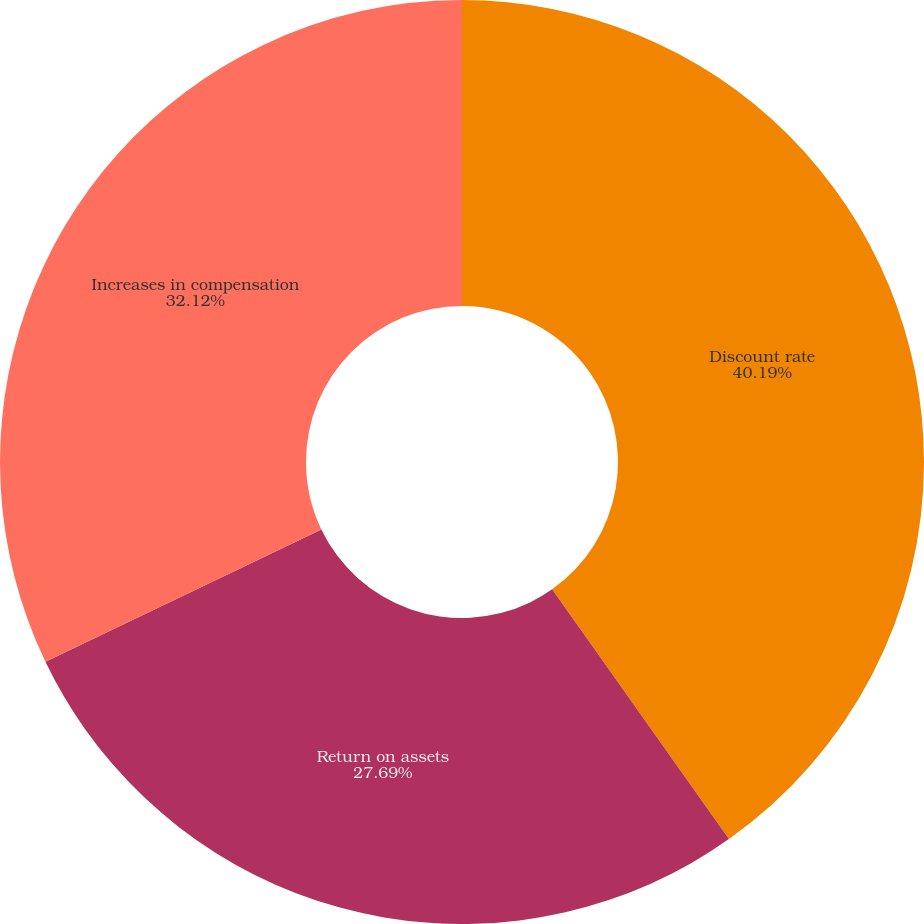Convert chart to OTSL. <chart><loc_0><loc_0><loc_500><loc_500><pie_chart><fcel>Discount rate<fcel>Return on assets<fcel>Increases in compensation<nl><fcel>40.2%<fcel>27.69%<fcel>32.12%<nl></chart> 